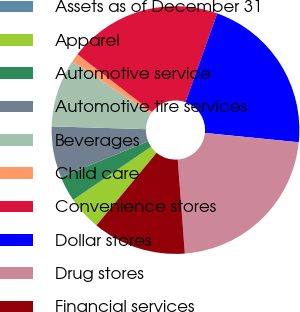Convert chart to OTSL. <chart><loc_0><loc_0><loc_500><loc_500><pie_chart><fcel>Assets as of December 31<fcel>Apparel<fcel>Automotive service<fcel>Automotive tire services<fcel>Beverages<fcel>Child care<fcel>Convenience stores<fcel>Dollar stores<fcel>Drug stores<fcel>Financial services<nl><fcel>0.0%<fcel>4.45%<fcel>3.33%<fcel>6.67%<fcel>8.89%<fcel>1.11%<fcel>20.0%<fcel>21.11%<fcel>22.22%<fcel>12.22%<nl></chart> 